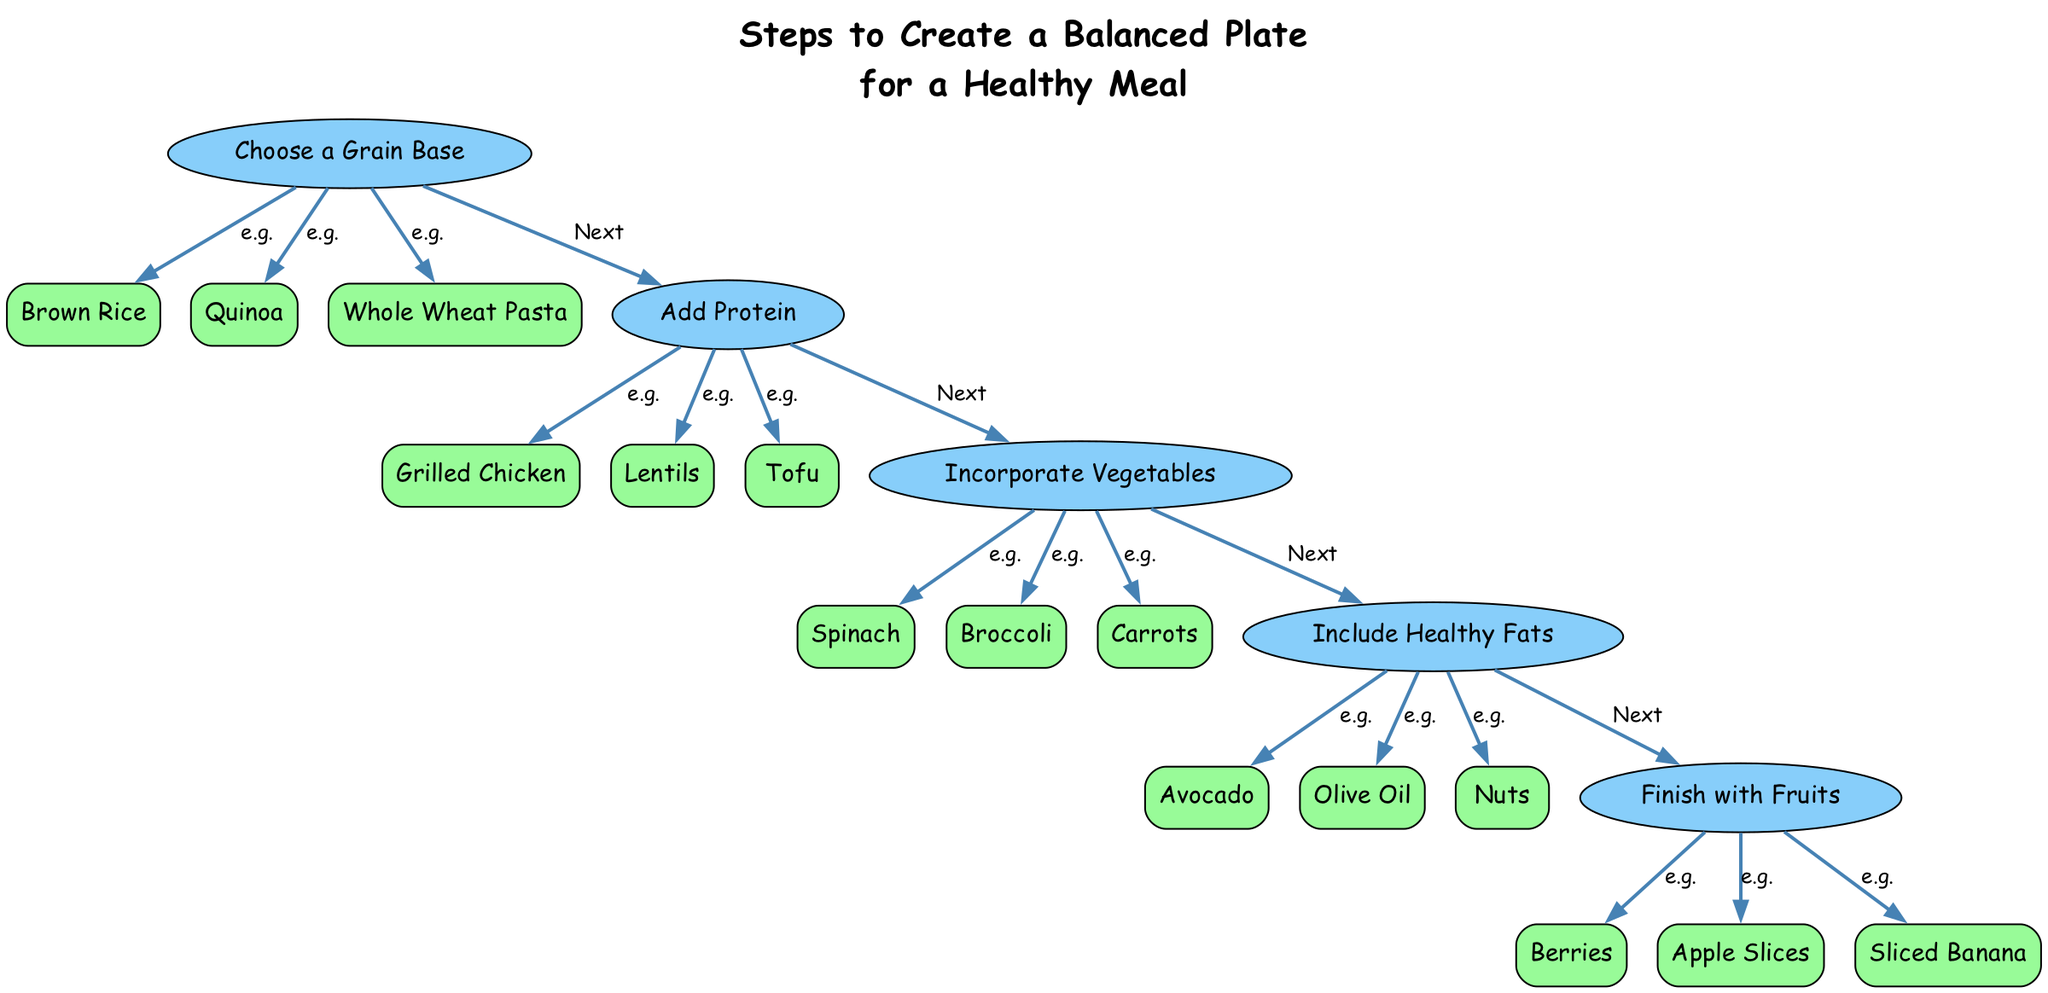What is the first step in creating a balanced plate? The diagram shows "Choose a Grain Base" as the first step at the top of the directed graph.
Answer: Choose a Grain Base How many types of grains are listed as examples? The directed graph lists three examples under the "Choose a Grain Base" step: Brown Rice, Quinoa, and Whole Wheat Pasta, leading to a count of three.
Answer: 3 Which step comes after adding protein? Following the "Add Protein" step, the next step in the directed graph is "Incorporate Vegetables." This relationship is indicated by a directed edge from "Add Protein" to "Incorporate Vegetables."
Answer: Incorporate Vegetables List one example of healthy fat. Under the step "Include Healthy Fats," the graph presents examples including Avocado, Olive Oil, and Nuts. Any one of these would be a valid answer.
Answer: Avocado How many steps are there in total? The directed graph outlines five distinct steps in the process of creating a balanced plate for a healthy meal, leading to a total count of five steps.
Answer: 5 What is the final step in this diagram? The last step in the directed graph is "Finish with Fruits," as it appears at the bottom of the flow. This is confirmed by examining the steps ordered from top to bottom.
Answer: Finish with Fruits Which nutrient category is connected to the example "Tofu"? The example "Tofu" is associated with the step "Add Protein." The directed edge connects the step to this specific example node.
Answer: Protein Identify one vegetable example listed in the diagram. The step "Incorporate Vegetables" contains examples such as Spinach, Broccoli, and Carrots, any of which can be selected as an answer.
Answer: Spinach Which step has the most examples listed? When reviewing the graph, each step has three examples, so they all equally possess the same number. Since the maximum does not surpass three across these nodes, it reflects uniformity.
Answer: All steps have 3 examples 